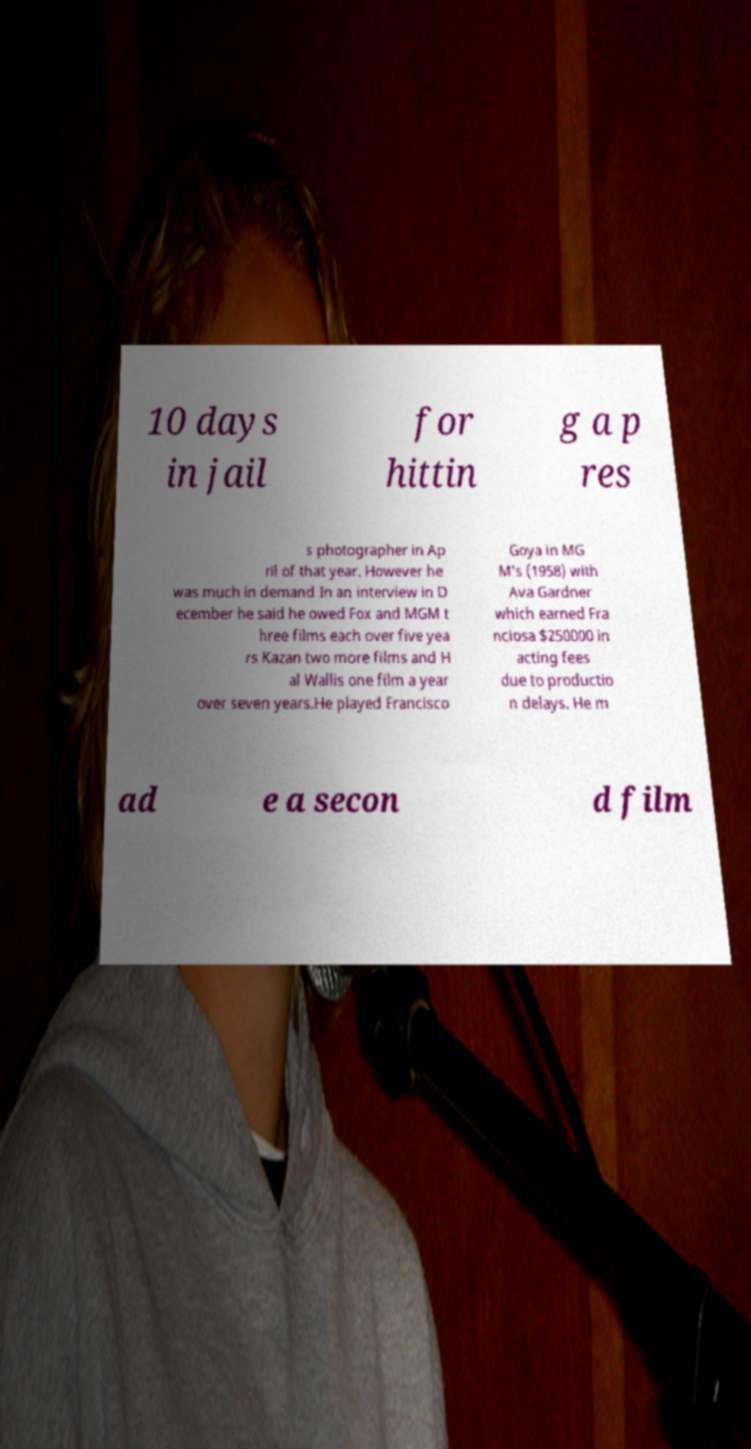Please identify and transcribe the text found in this image. 10 days in jail for hittin g a p res s photographer in Ap ril of that year. However he was much in demand In an interview in D ecember he said he owed Fox and MGM t hree films each over five yea rs Kazan two more films and H al Wallis one film a year over seven years.He played Francisco Goya in MG M's (1958) with Ava Gardner which earned Fra nciosa $250000 in acting fees due to productio n delays. He m ad e a secon d film 